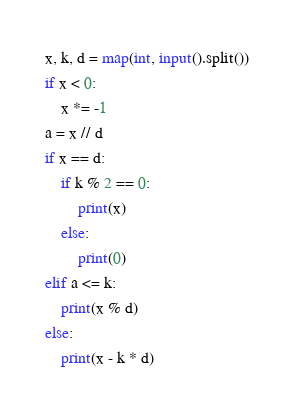Convert code to text. <code><loc_0><loc_0><loc_500><loc_500><_Python_>x, k, d = map(int, input().split())
if x < 0:
    x *= -1
a = x // d
if x == d:
    if k % 2 == 0:
        print(x)
    else:
        print(0)
elif a <= k:
    print(x % d)
else:
    print(x - k * d)
</code> 